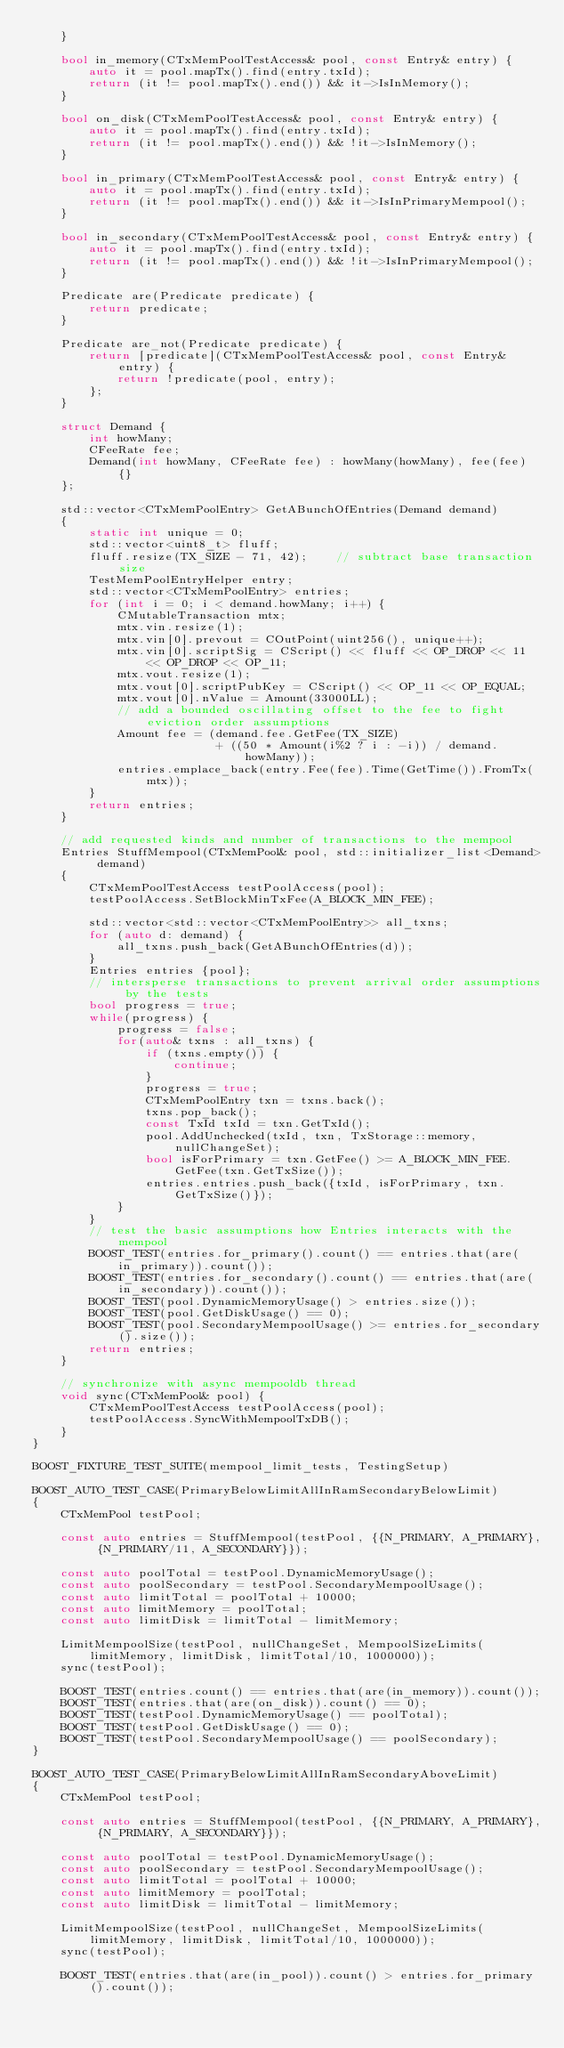Convert code to text. <code><loc_0><loc_0><loc_500><loc_500><_C++_>    }

    bool in_memory(CTxMemPoolTestAccess& pool, const Entry& entry) {
        auto it = pool.mapTx().find(entry.txId);
        return (it != pool.mapTx().end()) && it->IsInMemory();
    }

    bool on_disk(CTxMemPoolTestAccess& pool, const Entry& entry) {
        auto it = pool.mapTx().find(entry.txId);
        return (it != pool.mapTx().end()) && !it->IsInMemory();
    }

    bool in_primary(CTxMemPoolTestAccess& pool, const Entry& entry) {
        auto it = pool.mapTx().find(entry.txId);
        return (it != pool.mapTx().end()) && it->IsInPrimaryMempool();
    }

    bool in_secondary(CTxMemPoolTestAccess& pool, const Entry& entry) {
        auto it = pool.mapTx().find(entry.txId);
        return (it != pool.mapTx().end()) && !it->IsInPrimaryMempool();
    }

    Predicate are(Predicate predicate) {
        return predicate;
    }

	Predicate are_not(Predicate predicate) {
        return [predicate](CTxMemPoolTestAccess& pool, const Entry& entry) {
            return !predicate(pool, entry);
        };
    }

	struct Demand {
        int howMany;
        CFeeRate fee;
        Demand(int howMany, CFeeRate fee) : howMany(howMany), fee(fee) {}
    };

    std::vector<CTxMemPoolEntry> GetABunchOfEntries(Demand demand)
    {
        static int unique = 0;
        std::vector<uint8_t> fluff;
        fluff.resize(TX_SIZE - 71, 42);    // subtract base transaction size
        TestMemPoolEntryHelper entry;
        std::vector<CTxMemPoolEntry> entries;
        for (int i = 0; i < demand.howMany; i++) {
            CMutableTransaction mtx;
            mtx.vin.resize(1);
            mtx.vin[0].prevout = COutPoint(uint256(), unique++);
            mtx.vin[0].scriptSig = CScript() << fluff << OP_DROP << 11 << OP_DROP << OP_11;
            mtx.vout.resize(1);
            mtx.vout[0].scriptPubKey = CScript() << OP_11 << OP_EQUAL;
            mtx.vout[0].nValue = Amount(33000LL);
            // add a bounded oscillating offset to the fee to fight eviction order assumptions
            Amount fee = (demand.fee.GetFee(TX_SIZE)
                          + ((50 * Amount(i%2 ? i : -i)) / demand.howMany));
            entries.emplace_back(entry.Fee(fee).Time(GetTime()).FromTx(mtx));
        }
        return entries;
    }

    // add requested kinds and number of transactions to the mempool
    Entries StuffMempool(CTxMemPool& pool, std::initializer_list<Demand> demand)
    {
        CTxMemPoolTestAccess testPoolAccess(pool);
        testPoolAccess.SetBlockMinTxFee(A_BLOCK_MIN_FEE);

        std::vector<std::vector<CTxMemPoolEntry>> all_txns;
        for (auto d: demand) {
            all_txns.push_back(GetABunchOfEntries(d));
        }
        Entries entries {pool};
        // intersperse transactions to prevent arrival order assumptions by the tests
        bool progress = true;
        while(progress) {
            progress = false;
            for(auto& txns : all_txns) {
                if (txns.empty()) {
                    continue;
                }
                progress = true;
                CTxMemPoolEntry txn = txns.back();
                txns.pop_back();
                const TxId txId = txn.GetTxId();
                pool.AddUnchecked(txId, txn, TxStorage::memory, nullChangeSet);
                bool isForPrimary = txn.GetFee() >= A_BLOCK_MIN_FEE.GetFee(txn.GetTxSize());
                entries.entries.push_back({txId, isForPrimary, txn.GetTxSize()});
            }
        }
        // test the basic assumptions how Entries interacts with the mempool
        BOOST_TEST(entries.for_primary().count() == entries.that(are(in_primary)).count());
        BOOST_TEST(entries.for_secondary().count() == entries.that(are(in_secondary)).count());
        BOOST_TEST(pool.DynamicMemoryUsage() > entries.size());
        BOOST_TEST(pool.GetDiskUsage() == 0);
        BOOST_TEST(pool.SecondaryMempoolUsage() >= entries.for_secondary().size());
        return entries;
    }

	// synchronize with async mempooldb thread
	void sync(CTxMemPool& pool) {
        CTxMemPoolTestAccess testPoolAccess(pool);
        testPoolAccess.SyncWithMempoolTxDB();
    }
}

BOOST_FIXTURE_TEST_SUITE(mempool_limit_tests, TestingSetup)

BOOST_AUTO_TEST_CASE(PrimaryBelowLimitAllInRamSecondaryBelowLimit)
{
    CTxMemPool testPool;

    const auto entries = StuffMempool(testPool, {{N_PRIMARY, A_PRIMARY}, {N_PRIMARY/11, A_SECONDARY}});

    const auto poolTotal = testPool.DynamicMemoryUsage();
    const auto poolSecondary = testPool.SecondaryMempoolUsage();
    const auto limitTotal = poolTotal + 10000;
    const auto limitMemory = poolTotal;
    const auto limitDisk = limitTotal - limitMemory;

    LimitMempoolSize(testPool, nullChangeSet, MempoolSizeLimits(limitMemory, limitDisk, limitTotal/10, 1000000));
    sync(testPool);

    BOOST_TEST(entries.count() == entries.that(are(in_memory)).count());
    BOOST_TEST(entries.that(are(on_disk)).count() == 0);
    BOOST_TEST(testPool.DynamicMemoryUsage() == poolTotal);
    BOOST_TEST(testPool.GetDiskUsage() == 0);
    BOOST_TEST(testPool.SecondaryMempoolUsage() == poolSecondary);
}

BOOST_AUTO_TEST_CASE(PrimaryBelowLimitAllInRamSecondaryAboveLimit)
{
    CTxMemPool testPool;

    const auto entries = StuffMempool(testPool, {{N_PRIMARY, A_PRIMARY}, {N_PRIMARY, A_SECONDARY}});

    const auto poolTotal = testPool.DynamicMemoryUsage();
    const auto poolSecondary = testPool.SecondaryMempoolUsage();
    const auto limitTotal = poolTotal + 10000;
    const auto limitMemory = poolTotal;
    const auto limitDisk = limitTotal - limitMemory;

    LimitMempoolSize(testPool, nullChangeSet, MempoolSizeLimits(limitMemory, limitDisk, limitTotal/10, 1000000));
    sync(testPool);

    BOOST_TEST(entries.that(are(in_pool)).count() > entries.for_primary().count());</code> 